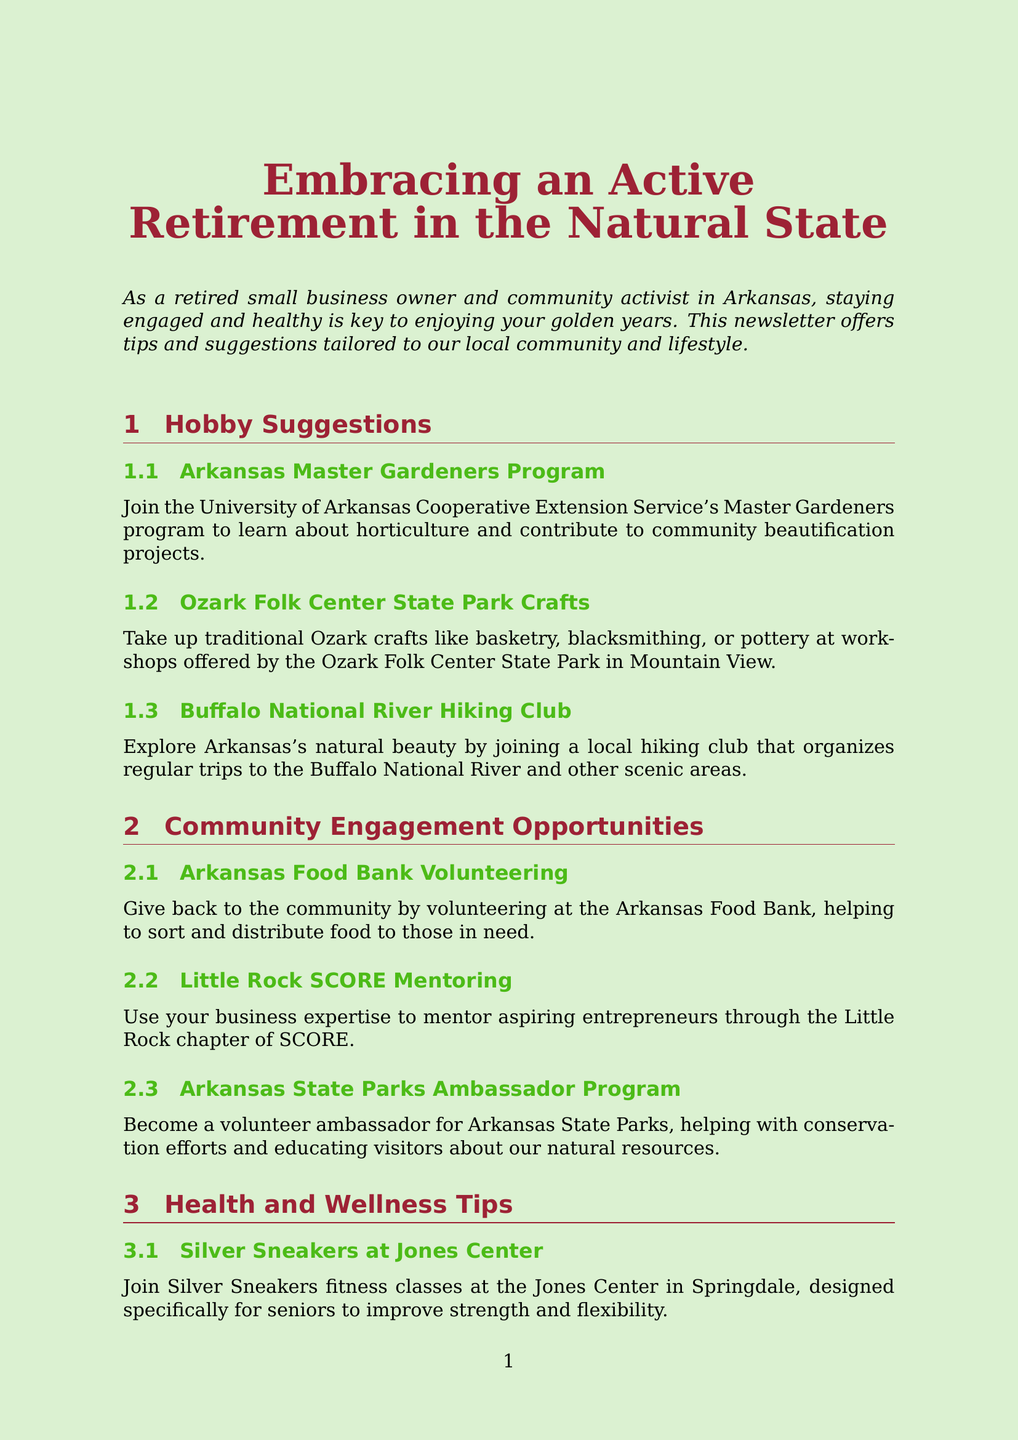What is the title of the newsletter? The title of the newsletter is stated at the beginning of the document.
Answer: Embracing an Active Retirement in the Natural State What program can you join to learn about horticulture? The document mentions a specific program related to horticulture in the hobby suggestions.
Answer: Arkansas Master Gardeners Program Which city offers the Silver Sneakers fitness classes? The document specifies the location of the fitness classes designed for seniors.
Answer: Springdale What opportunity allows you to volunteer at the Arkansas Food Bank? The volunteering opportunity described in the community engagement section highlights a specific food bank.
Answer: Arkansas Food Bank Volunteering How can retired teachers stay connected with other retirees? This question focuses on the local resources for retired teachers in the document.
Answer: Arkansas Retired Teachers Association What type of activities are included in the Arkansas Senior Olympics? This asks for the nature of participation mentioned in the health and wellness tips.
Answer: Sports and activities What is a benefit of joining the UAMS Longevity Clinic? The document outlines a specific service provided by the longevity clinic for retired individuals.
Answer: Specialized geriatric care What craft activities can you take up at the Ozark Folk Center State Park? The document lists specific traditional crafts available to retirees.
Answer: Basketry, blacksmithing, or pottery Which program helps mentor aspiring entrepreneurs? This question points to a community engagement opportunity aimed at supporting new business owners.
Answer: Little Rock SCORE Mentoring 